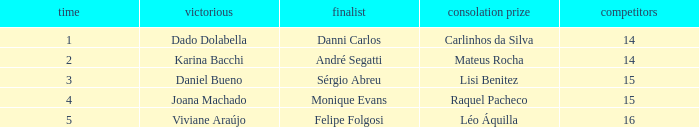Would you mind parsing the complete table? {'header': ['time', 'victorious', 'finalist', 'consolation prize', 'competitors'], 'rows': [['1', 'Dado Dolabella', 'Danni Carlos', 'Carlinhos da Silva', '14'], ['2', 'Karina Bacchi', 'André Segatti', 'Mateus Rocha', '14'], ['3', 'Daniel Bueno', 'Sérgio Abreu', 'Lisi Benitez', '15'], ['4', 'Joana Machado', 'Monique Evans', 'Raquel Pacheco', '15'], ['5', 'Viviane Araújo', 'Felipe Folgosi', 'Léo Áquilla', '16']]} Who was the winner when Mateus Rocha finished in 3rd place?  Karina Bacchi. 